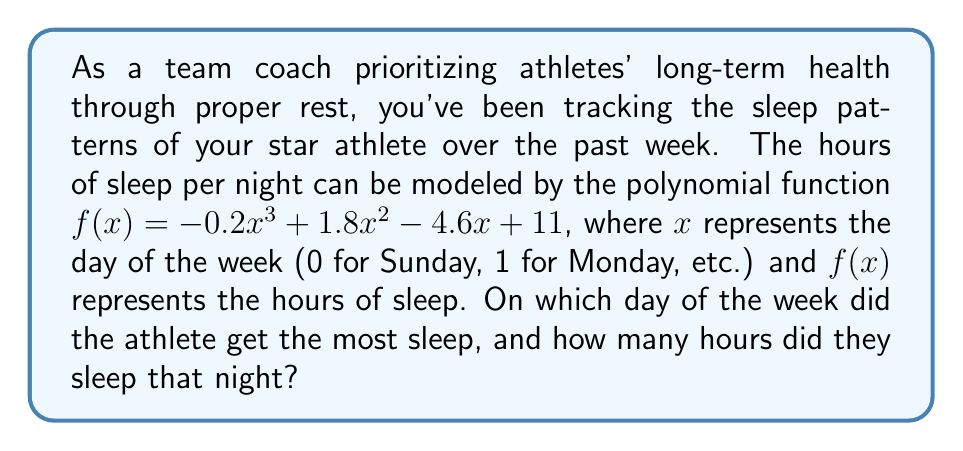Solve this math problem. To solve this problem, we need to find the maximum value of the function $f(x) = -0.2x^3 + 1.8x^2 - 4.6x + 11$ within the domain $[0, 6]$, representing the days of the week.

1) First, let's find the critical points by taking the derivative of $f(x)$ and setting it equal to zero:

   $f'(x) = -0.6x^2 + 3.6x - 4.6$

2) Set $f'(x) = 0$:
   $-0.6x^2 + 3.6x - 4.6 = 0$

3) This is a quadratic equation. We can solve it using the quadratic formula:
   $x = \frac{-b \pm \sqrt{b^2 - 4ac}}{2a}$

   Where $a = -0.6$, $b = 3.6$, and $c = -4.6$

4) Plugging in these values:
   $x = \frac{-3.6 \pm \sqrt{3.6^2 - 4(-0.6)(-4.6)}}{2(-0.6)}$

5) Simplifying:
   $x = \frac{-3.6 \pm \sqrt{12.96 - 11.04}}{-1.2} = \frac{-3.6 \pm \sqrt{1.92}}{-1.2} = \frac{-3.6 \pm 1.3856}{-1.2}$

6) This gives us two critical points:
   $x_1 = \frac{-3.6 + 1.3856}{-1.2} \approx 1.8453$
   $x_2 = \frac{-3.6 - 1.3856}{-1.2} \approx 4.1547$

7) Since we're looking at days of the week, we need to consider only integer values of $x$ from 0 to 6. The critical points suggest that the maximum could occur around day 2 (Tuesday) or day 4 (Thursday).

8) Let's evaluate $f(x)$ for $x = 1, 2, 3, 4, 5$:
   $f(1) = -0.2(1)^3 + 1.8(1)^2 - 4.6(1) + 11 = 8$
   $f(2) = -0.2(2)^3 + 1.8(2)^2 - 4.6(2) + 11 = 8.4$
   $f(3) = -0.2(3)^3 + 1.8(3)^2 - 4.6(3) + 11 = 8.6$
   $f(4) = -0.2(4)^3 + 1.8(4)^2 - 4.6(4) + 11 = 8.4$
   $f(5) = -0.2(5)^3 + 1.8(5)^2 - 4.6(5) + 11 = 7.5$

9) We can see that the maximum occurs when $x = 3$, which corresponds to Wednesday.

Therefore, the athlete got the most sleep on Wednesday, sleeping for 8.6 hours.
Answer: The athlete got the most sleep on Wednesday, sleeping for 8.6 hours. 